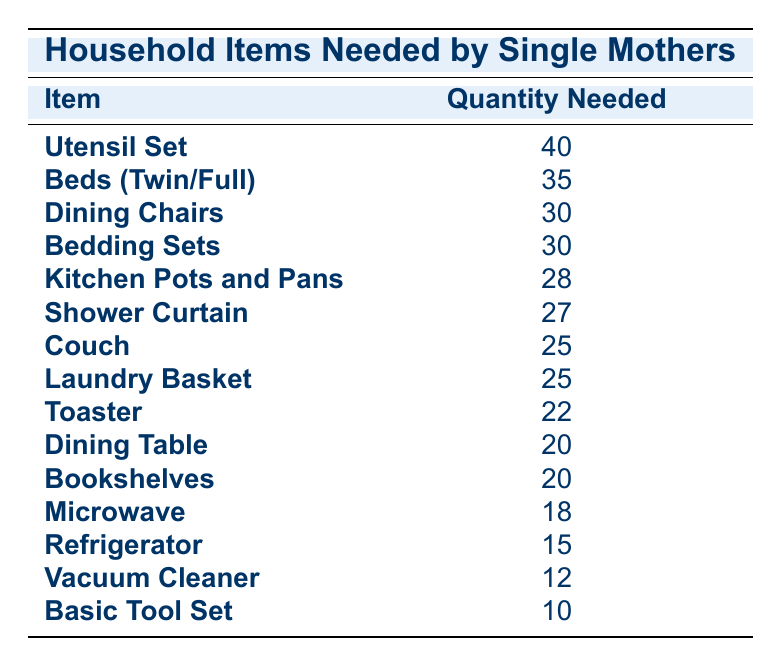What is the item with the highest quantity needed? The table shows the "Utensil Set" with a quantity needed of 40, the highest among all listed items.
Answer: Utensil Set How many dining chairs are needed? Referring to the table, the quantity needed for "Dining Chairs" is stated as 30.
Answer: 30 Are more bedding sets needed than couches? The table shows that the quantity needed for "Bedding Sets" is 30 and for "Couch," it is 25. Since 30 is greater than 25, the answer is yes.
Answer: Yes What is the combined quantity of kitchen pots, pans, and shower curtains? The quantity needed for "Kitchen Pots and Pans" is 28 and for "Shower Curtain," it is 27. Adding these gives 28 + 27 = 55.
Answer: 55 What is the average quantity needed for the items listed? To find the average, sum all quantity values: 40 + 35 + 30 + 30 + 28 + 27 + 25 + 25 + 22 + 20 + 20 + 18 + 15 + 12 + 10 =  392. There are 15 items, so the average is 392 / 15 ≈ 26.13.
Answer: 26.13 Is the quantity of microwaves needed greater than that of refrigerators? The table indicates that 18 microwaves are needed and 15 refrigerators, thus 18 is greater than 15, making the answer yes.
Answer: Yes What is the difference between the quantity needed for utensil sets and vacuum cleaners? The table indicates that 40 utensil sets are needed and 12 vacuum cleaners. To find the difference, subtract 12 from 40, which equals 28.
Answer: 28 How many total items need to be acquired if only the top 5 items are considered? The top five items are Utensil Set (40), Beds (Twin/Full) (35), Dining Chairs (30), Bedding Sets (30), and Kitchen Pots and Pans (28). Adding these quantities together gives 40 + 35 + 30 + 30 + 28 = 163.
Answer: 163 